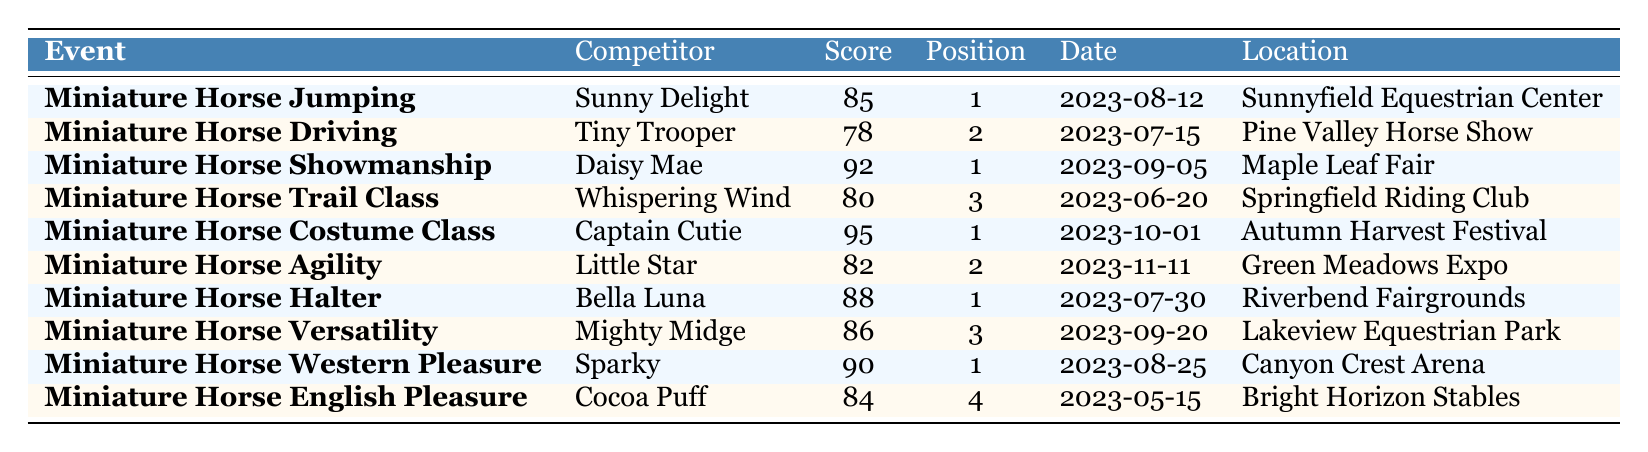What is the highest score achieved in a single event? The highest score listed in the table is 95, which was achieved by Captain Cutie in the Miniature Horse Costume Class.
Answer: 95 Who finished in first place in the Miniature Horse Showmanship event? Daisy Mae finished in first place in Miniature Horse Showmanship with a score of 92 on September 5, 2023.
Answer: Daisy Mae Was there a competitor that received a score of 84 in any event? Yes, Cocoa Puff received a score of 84 in the Miniature Horse English Pleasure event.
Answer: Yes Which event had the lowest scoring competitor? The lowest score in the table is 78, received by Tiny Trooper in the Miniature Horse Driving event.
Answer: Miniature Horse Driving What is the total number of first place finishes recorded? There are 5 competitors who finished in first place across various events: Sunny Delight, Daisy Mae, Captain Cutie, Bella Luna, and Sparky.
Answer: 5 Which location hosted the Miniature Horse Trail Class? The Miniature Horse Trail Class took place at Springfield Riding Club.
Answer: Springfield Riding Club Did any competitor score above 90? Yes, both Captain Cutie and Sparky scored above 90, with scores of 95 and 90, respectively.
Answer: Yes Which event had the most competitors with a score above 80? The Miniature Horse Halter event had a competitor, Bella Luna, scoring 88, while the Costume Class had Captain Cutie with a score of 95; thus, both events only had one competitor each above 80, so we need to check all events. In total, four events had scores above 80: Miniature Horse Costume Class, Miniature Horse Showmanship, Miniature Horse Western Pleasure, and Miniature Horse Halter. Thus, this question is trivial.
Answer: Four events What was the average score of the competitors in the Miniature Horse Driving and Miniature Horse Trail Class combined? The scores for Miniature Horse Driving and Miniature Horse Trail Class are 78 and 80 respectively. Adding these scores together gives 78 + 80 = 158. Dividing this by 2 gives an average score of 79.
Answer: 79 